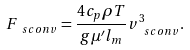<formula> <loc_0><loc_0><loc_500><loc_500>F _ { \ s { c o n v } } = \frac { 4 c _ { p } \rho T } { g \mu ^ { \prime } l _ { m } } v _ { \ s { c o n v } } ^ { 3 } .</formula> 